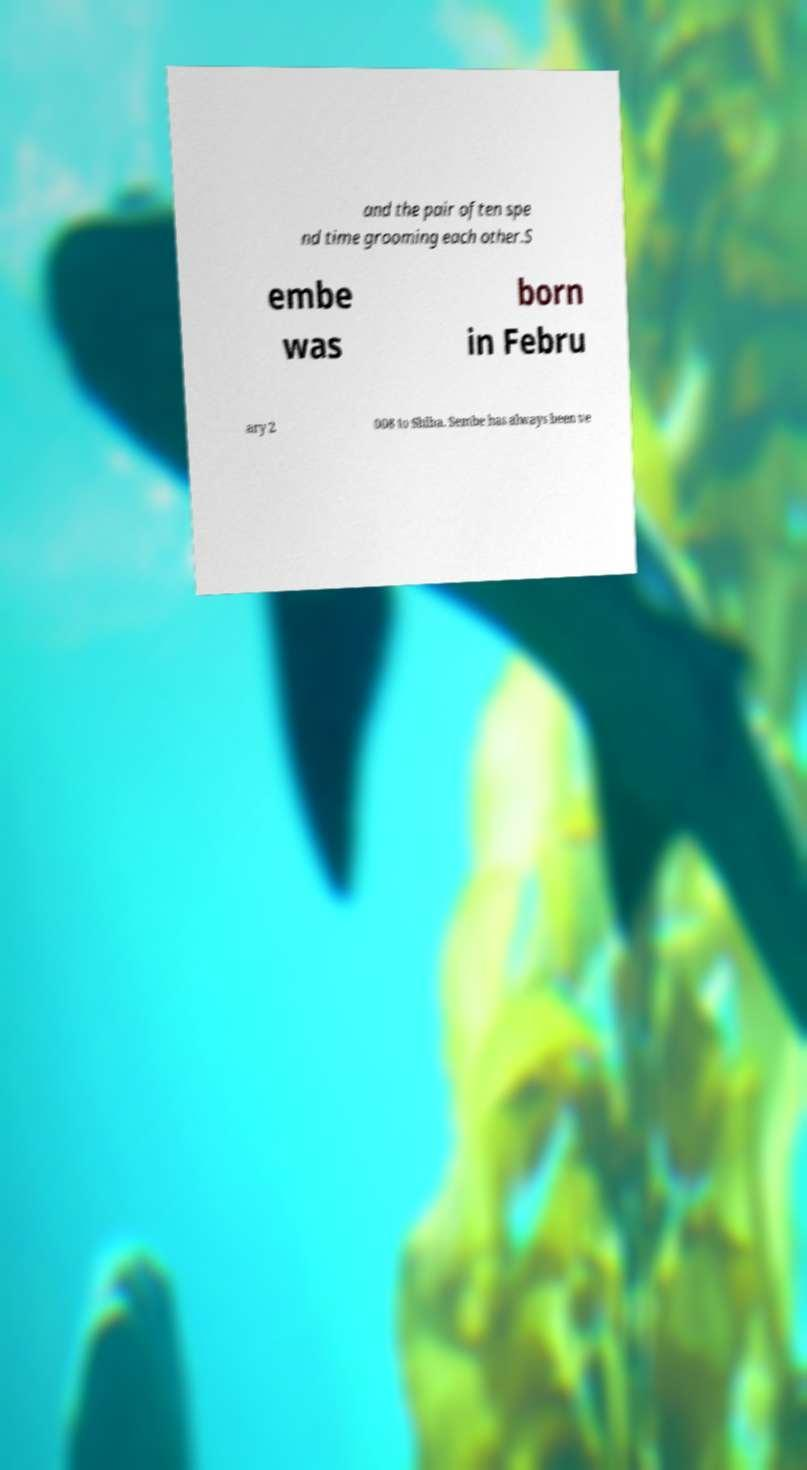Please identify and transcribe the text found in this image. and the pair often spe nd time grooming each other.S embe was born in Febru ary 2 008 to Shiba. Sembe has always been ve 